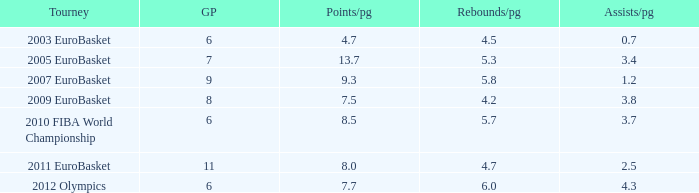How many games played have 4.7 points per game? 1.0. 